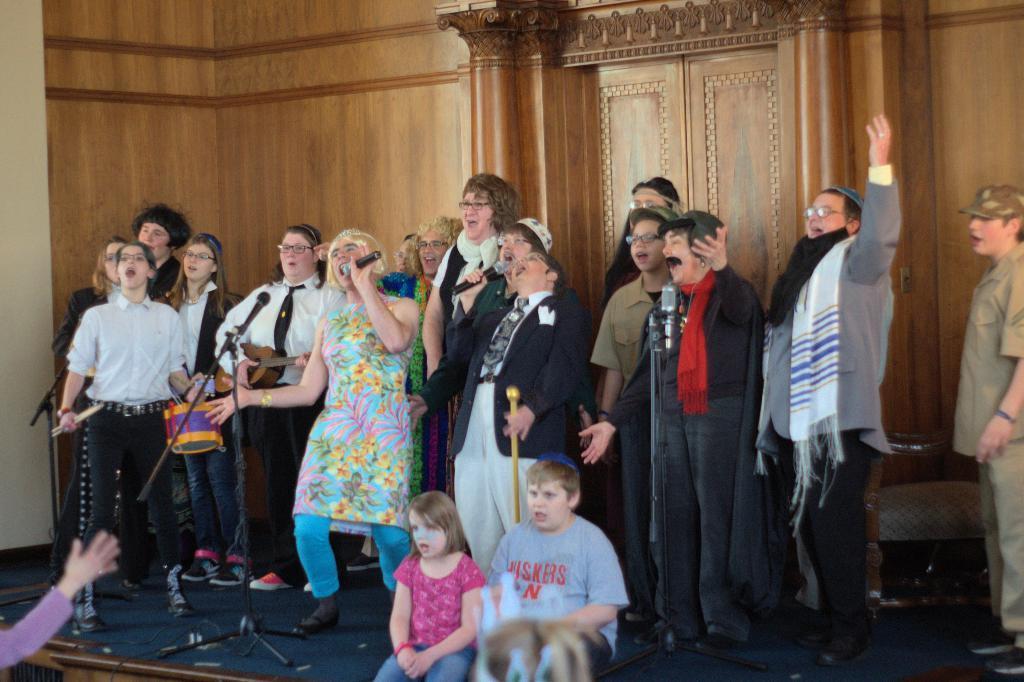Please provide a concise description of this image. In this image we can see a few people on the stage, some of them are holding mics and singing, there is a chair and stands, there are two kids sitting on the stage, also we an see the wooden wall, and pillars. 